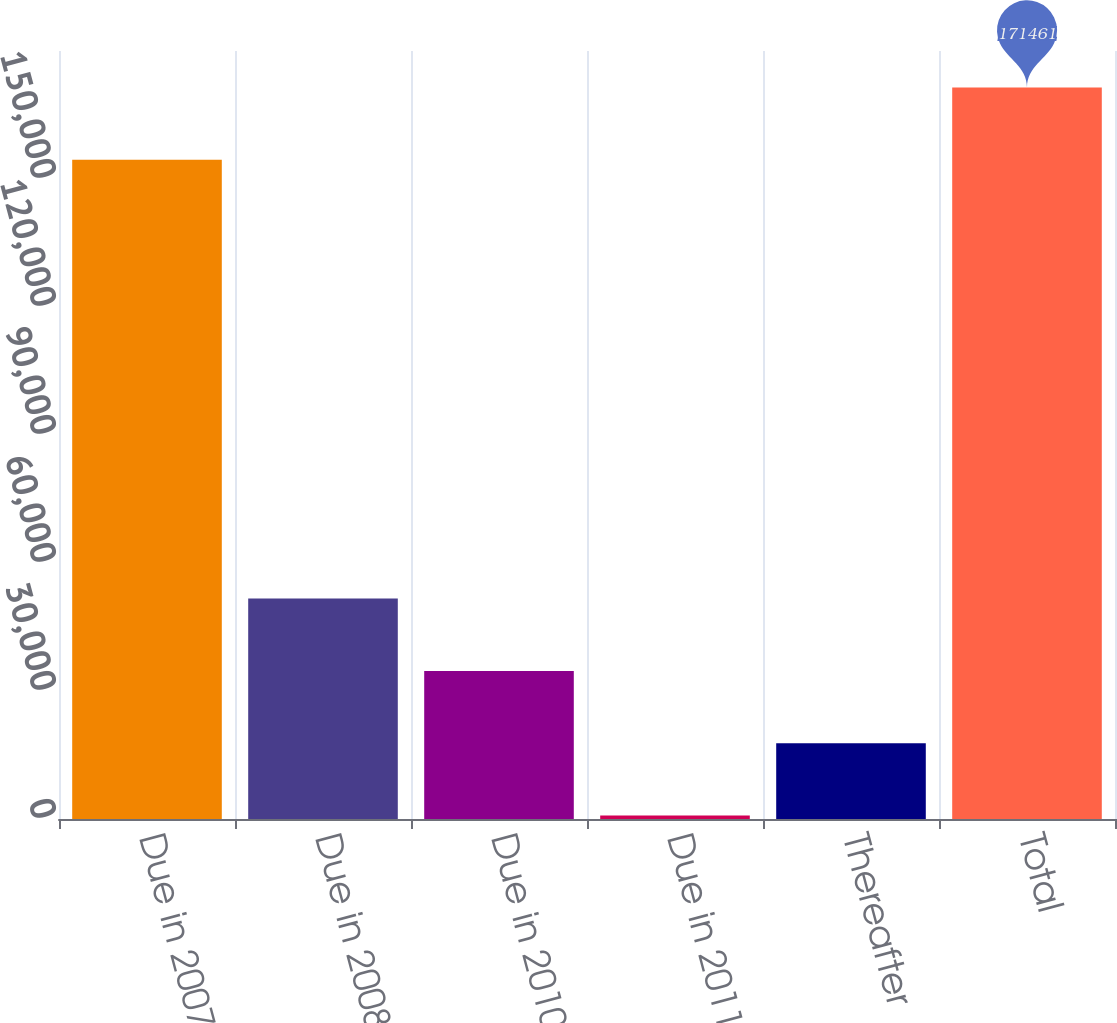Convert chart to OTSL. <chart><loc_0><loc_0><loc_500><loc_500><bar_chart><fcel>Due in 2007<fcel>Due in 2008<fcel>Due in 2010<fcel>Due in 2011<fcel>Thereafter<fcel>Total<nl><fcel>154509<fcel>51663<fcel>34711<fcel>807<fcel>17759<fcel>171461<nl></chart> 